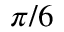<formula> <loc_0><loc_0><loc_500><loc_500>\pi / 6</formula> 